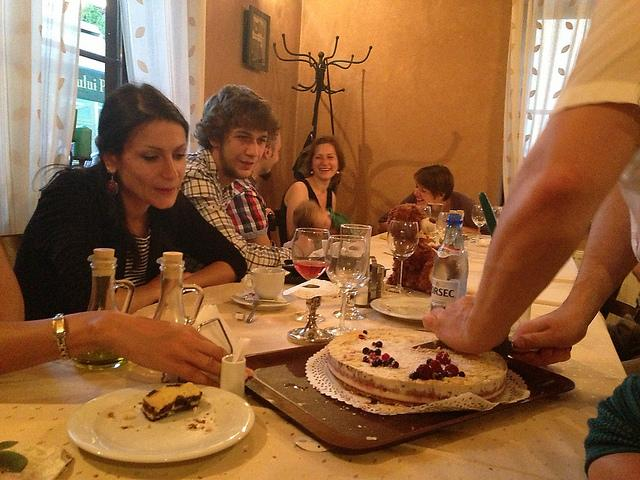What will the people shown here have for dessert? cheesecake 